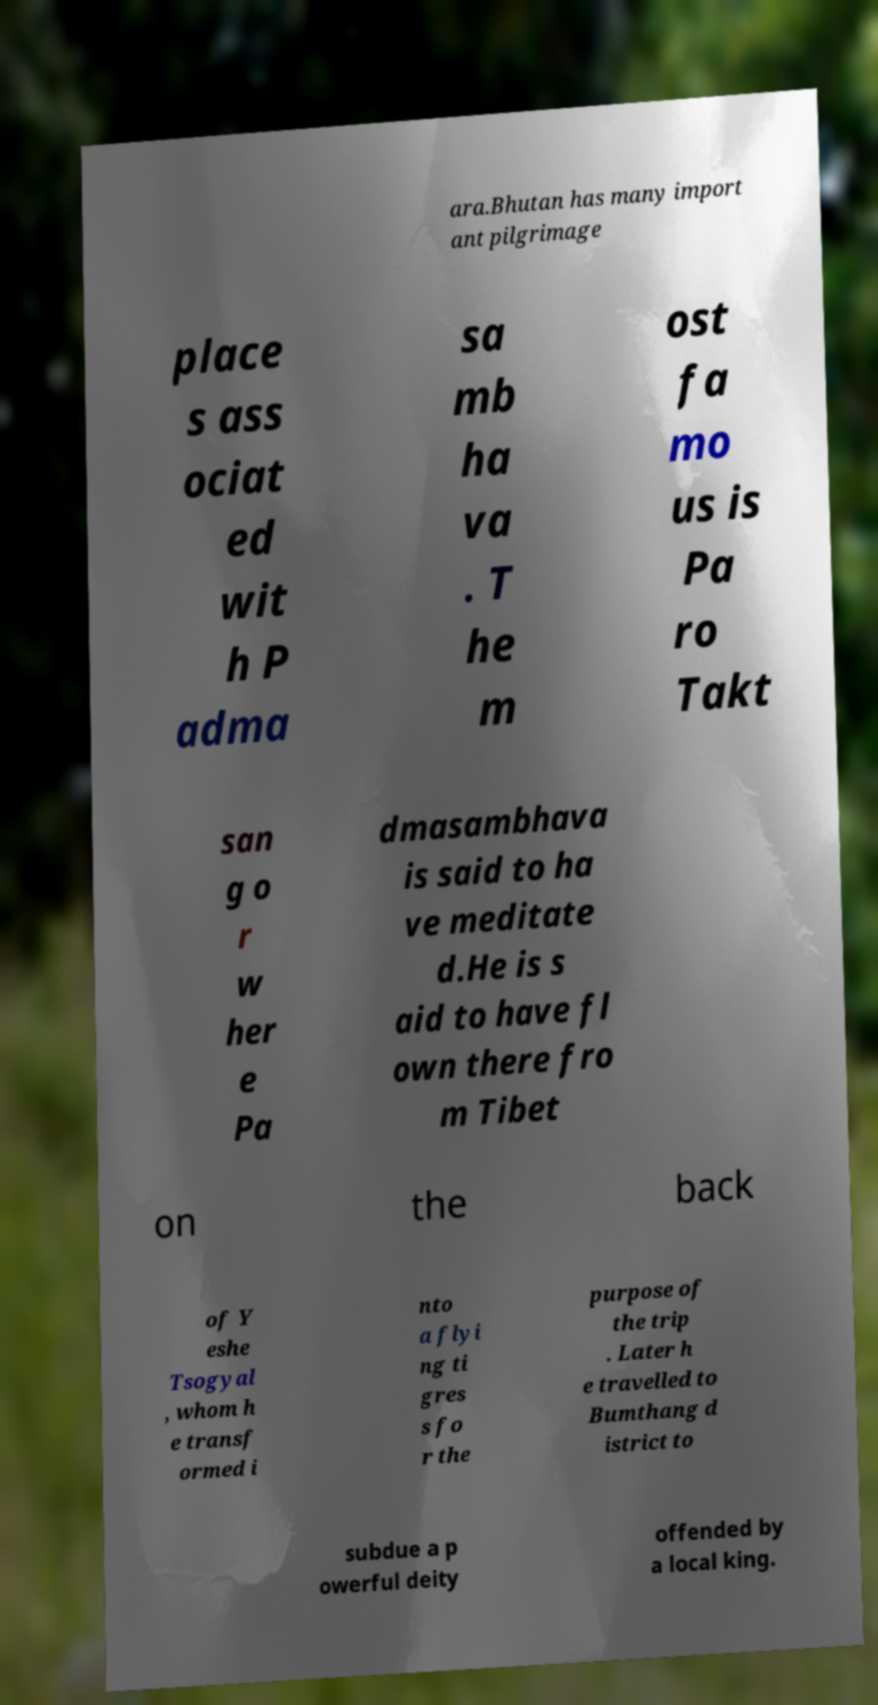Could you extract and type out the text from this image? ara.Bhutan has many import ant pilgrimage place s ass ociat ed wit h P adma sa mb ha va . T he m ost fa mo us is Pa ro Takt san g o r w her e Pa dmasambhava is said to ha ve meditate d.He is s aid to have fl own there fro m Tibet on the back of Y eshe Tsogyal , whom h e transf ormed i nto a flyi ng ti gres s fo r the purpose of the trip . Later h e travelled to Bumthang d istrict to subdue a p owerful deity offended by a local king. 